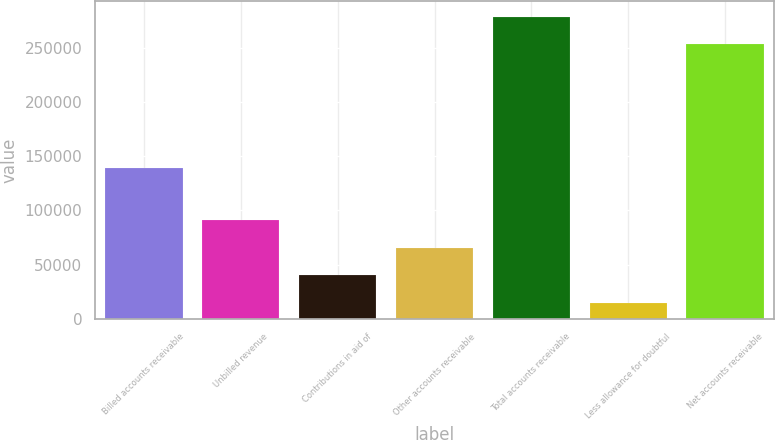<chart> <loc_0><loc_0><loc_500><loc_500><bar_chart><fcel>Billed accounts receivable<fcel>Unbilled revenue<fcel>Contributions in aid of<fcel>Other accounts receivable<fcel>Total accounts receivable<fcel>Less allowance for doubtful<fcel>Net accounts receivable<nl><fcel>138794<fcel>90783.5<fcel>40124.5<fcel>65454<fcel>278624<fcel>14795<fcel>253295<nl></chart> 